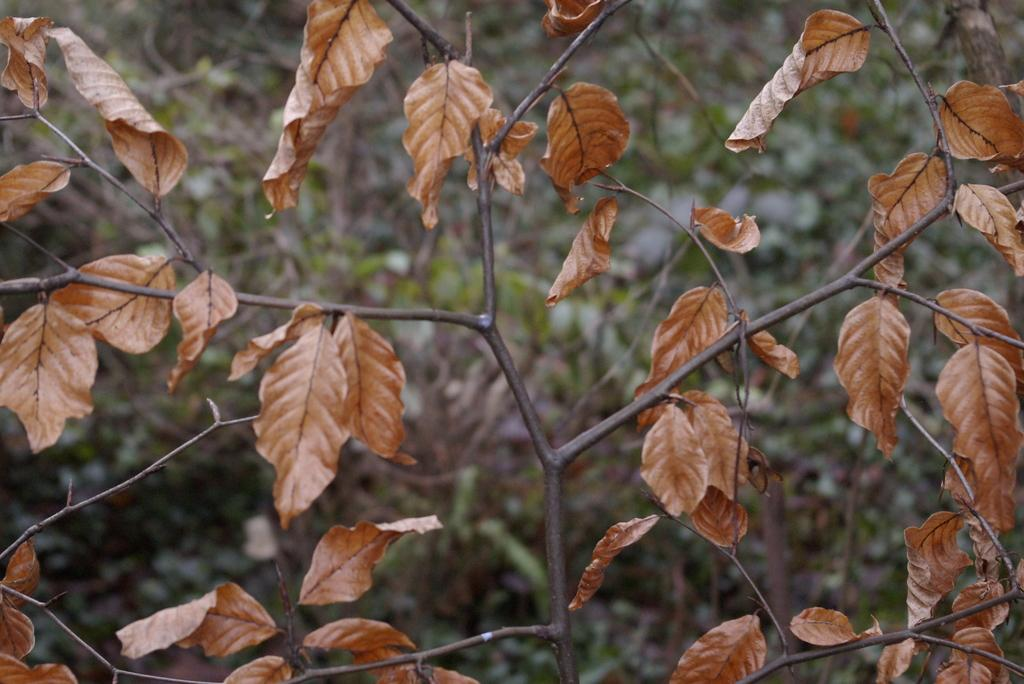What type of vegetation can be seen in the image? There are trees in the image. What type of potato is being served by the lawyer in the image? There is no potato or lawyer present in the image; it only features trees. 